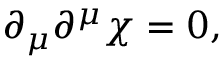Convert formula to latex. <formula><loc_0><loc_0><loc_500><loc_500>\partial _ { \mu } \partial ^ { \mu } \chi = 0 ,</formula> 